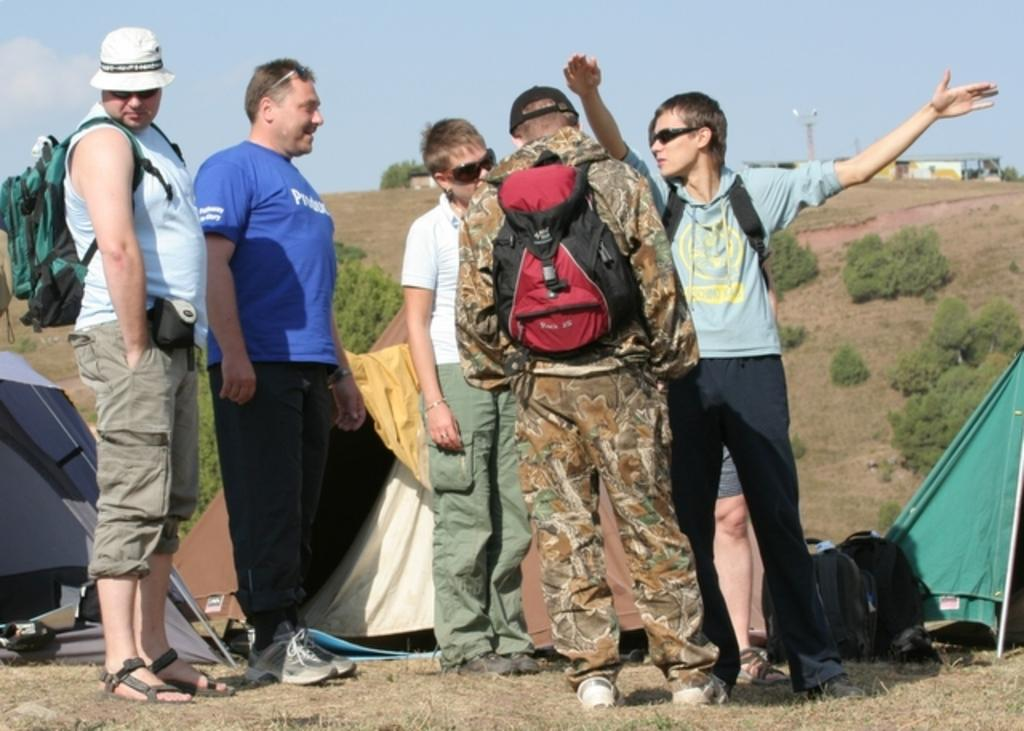How many people are in the image? There is a group of people in the image, but the exact number is not specified. What are some of the people wearing in the image? Some people are wearing backpacks and goggles in the image. What type of shelter is visible in the image? There are tents in the image. What items are present for carrying belongings? There are bags in the image. What type of vegetation is present in the image? There are plants in the image. What is visible at the top of the image? The sky is visible at the top of the image. What type of oven is being used by the people in the image? There is no oven present in the image. Are the people on vacation in the image? The image does not provide any information about the people being on vacation. 